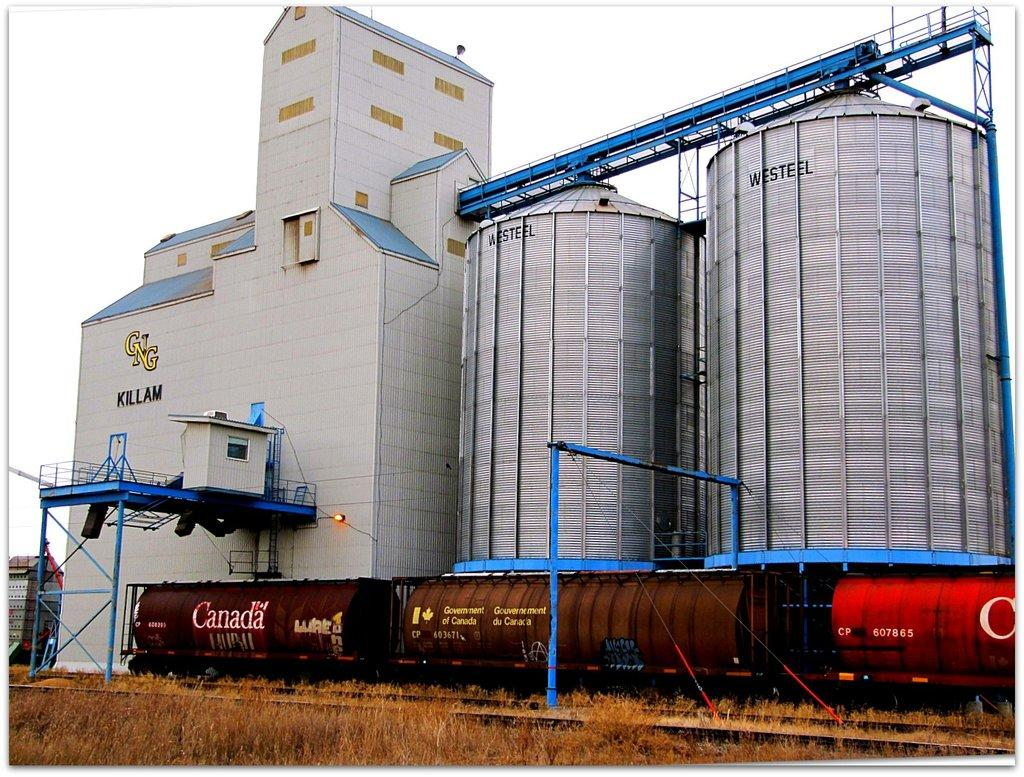What type of structure is present in the image? There is a building in the image. What is written on the building? The building has "WESTEEL'S" written on it. What can be seen in the sky in the image? There is sky visible in the image. What type of vegetation is in front of the building? There is grass in front of the building. What type of transportation infrastructure is present in front of the building? There is a railway track in front of the building. What color is the tongue of the person standing in front of the building? There is no person or tongue present in the image. What type of stem is growing from the grass in front of the building? There is no stem growing from the grass in the image; it is simply grass. 